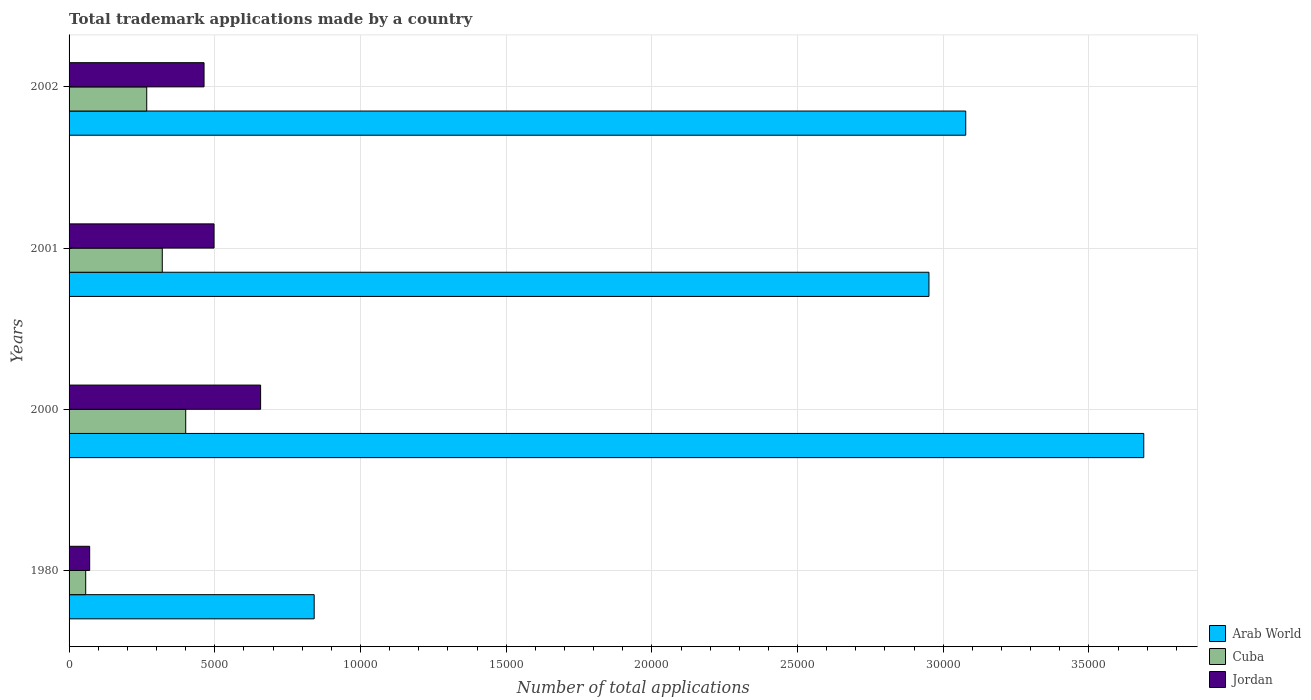Are the number of bars on each tick of the Y-axis equal?
Offer a very short reply. Yes. How many bars are there on the 2nd tick from the top?
Offer a terse response. 3. How many bars are there on the 1st tick from the bottom?
Your response must be concise. 3. What is the label of the 3rd group of bars from the top?
Make the answer very short. 2000. What is the number of applications made by in Jordan in 2001?
Provide a short and direct response. 4975. Across all years, what is the maximum number of applications made by in Jordan?
Offer a very short reply. 6573. Across all years, what is the minimum number of applications made by in Arab World?
Ensure brevity in your answer.  8411. In which year was the number of applications made by in Cuba maximum?
Make the answer very short. 2000. What is the total number of applications made by in Jordan in the graph?
Ensure brevity in your answer.  1.69e+04. What is the difference between the number of applications made by in Arab World in 1980 and that in 2001?
Offer a terse response. -2.11e+04. What is the difference between the number of applications made by in Cuba in 2001 and the number of applications made by in Arab World in 2002?
Ensure brevity in your answer.  -2.76e+04. What is the average number of applications made by in Arab World per year?
Give a very brief answer. 2.64e+04. In the year 2002, what is the difference between the number of applications made by in Jordan and number of applications made by in Arab World?
Make the answer very short. -2.61e+04. In how many years, is the number of applications made by in Jordan greater than 6000 ?
Give a very brief answer. 1. What is the ratio of the number of applications made by in Arab World in 2000 to that in 2001?
Make the answer very short. 1.25. What is the difference between the highest and the second highest number of applications made by in Arab World?
Ensure brevity in your answer.  6110. What is the difference between the highest and the lowest number of applications made by in Cuba?
Your response must be concise. 3432. Is the sum of the number of applications made by in Arab World in 2000 and 2001 greater than the maximum number of applications made by in Cuba across all years?
Ensure brevity in your answer.  Yes. What does the 3rd bar from the top in 2002 represents?
Your response must be concise. Arab World. What does the 3rd bar from the bottom in 2001 represents?
Keep it short and to the point. Jordan. Are all the bars in the graph horizontal?
Keep it short and to the point. Yes. How many years are there in the graph?
Give a very brief answer. 4. What is the difference between two consecutive major ticks on the X-axis?
Ensure brevity in your answer.  5000. Are the values on the major ticks of X-axis written in scientific E-notation?
Ensure brevity in your answer.  No. Does the graph contain any zero values?
Your answer should be compact. No. How many legend labels are there?
Your answer should be compact. 3. What is the title of the graph?
Keep it short and to the point. Total trademark applications made by a country. What is the label or title of the X-axis?
Ensure brevity in your answer.  Number of total applications. What is the label or title of the Y-axis?
Offer a terse response. Years. What is the Number of total applications in Arab World in 1980?
Your response must be concise. 8411. What is the Number of total applications of Cuba in 1980?
Keep it short and to the point. 571. What is the Number of total applications of Jordan in 1980?
Give a very brief answer. 707. What is the Number of total applications in Arab World in 2000?
Your response must be concise. 3.69e+04. What is the Number of total applications of Cuba in 2000?
Provide a succinct answer. 4003. What is the Number of total applications of Jordan in 2000?
Provide a short and direct response. 6573. What is the Number of total applications of Arab World in 2001?
Provide a succinct answer. 2.95e+04. What is the Number of total applications of Cuba in 2001?
Your response must be concise. 3199. What is the Number of total applications in Jordan in 2001?
Offer a terse response. 4975. What is the Number of total applications in Arab World in 2002?
Provide a succinct answer. 3.08e+04. What is the Number of total applications in Cuba in 2002?
Keep it short and to the point. 2665. What is the Number of total applications of Jordan in 2002?
Your answer should be compact. 4632. Across all years, what is the maximum Number of total applications in Arab World?
Offer a very short reply. 3.69e+04. Across all years, what is the maximum Number of total applications of Cuba?
Provide a succinct answer. 4003. Across all years, what is the maximum Number of total applications of Jordan?
Ensure brevity in your answer.  6573. Across all years, what is the minimum Number of total applications of Arab World?
Your answer should be compact. 8411. Across all years, what is the minimum Number of total applications of Cuba?
Your answer should be very brief. 571. Across all years, what is the minimum Number of total applications of Jordan?
Offer a terse response. 707. What is the total Number of total applications of Arab World in the graph?
Ensure brevity in your answer.  1.06e+05. What is the total Number of total applications of Cuba in the graph?
Offer a very short reply. 1.04e+04. What is the total Number of total applications in Jordan in the graph?
Your answer should be very brief. 1.69e+04. What is the difference between the Number of total applications of Arab World in 1980 and that in 2000?
Provide a short and direct response. -2.85e+04. What is the difference between the Number of total applications in Cuba in 1980 and that in 2000?
Provide a succinct answer. -3432. What is the difference between the Number of total applications of Jordan in 1980 and that in 2000?
Provide a succinct answer. -5866. What is the difference between the Number of total applications of Arab World in 1980 and that in 2001?
Ensure brevity in your answer.  -2.11e+04. What is the difference between the Number of total applications in Cuba in 1980 and that in 2001?
Ensure brevity in your answer.  -2628. What is the difference between the Number of total applications of Jordan in 1980 and that in 2001?
Ensure brevity in your answer.  -4268. What is the difference between the Number of total applications in Arab World in 1980 and that in 2002?
Give a very brief answer. -2.24e+04. What is the difference between the Number of total applications in Cuba in 1980 and that in 2002?
Offer a terse response. -2094. What is the difference between the Number of total applications of Jordan in 1980 and that in 2002?
Make the answer very short. -3925. What is the difference between the Number of total applications of Arab World in 2000 and that in 2001?
Keep it short and to the point. 7372. What is the difference between the Number of total applications of Cuba in 2000 and that in 2001?
Ensure brevity in your answer.  804. What is the difference between the Number of total applications of Jordan in 2000 and that in 2001?
Keep it short and to the point. 1598. What is the difference between the Number of total applications of Arab World in 2000 and that in 2002?
Your answer should be compact. 6110. What is the difference between the Number of total applications of Cuba in 2000 and that in 2002?
Offer a terse response. 1338. What is the difference between the Number of total applications in Jordan in 2000 and that in 2002?
Offer a terse response. 1941. What is the difference between the Number of total applications of Arab World in 2001 and that in 2002?
Offer a terse response. -1262. What is the difference between the Number of total applications of Cuba in 2001 and that in 2002?
Your answer should be very brief. 534. What is the difference between the Number of total applications in Jordan in 2001 and that in 2002?
Your answer should be very brief. 343. What is the difference between the Number of total applications of Arab World in 1980 and the Number of total applications of Cuba in 2000?
Offer a very short reply. 4408. What is the difference between the Number of total applications in Arab World in 1980 and the Number of total applications in Jordan in 2000?
Keep it short and to the point. 1838. What is the difference between the Number of total applications of Cuba in 1980 and the Number of total applications of Jordan in 2000?
Make the answer very short. -6002. What is the difference between the Number of total applications of Arab World in 1980 and the Number of total applications of Cuba in 2001?
Offer a terse response. 5212. What is the difference between the Number of total applications in Arab World in 1980 and the Number of total applications in Jordan in 2001?
Provide a short and direct response. 3436. What is the difference between the Number of total applications in Cuba in 1980 and the Number of total applications in Jordan in 2001?
Your answer should be compact. -4404. What is the difference between the Number of total applications of Arab World in 1980 and the Number of total applications of Cuba in 2002?
Make the answer very short. 5746. What is the difference between the Number of total applications in Arab World in 1980 and the Number of total applications in Jordan in 2002?
Offer a terse response. 3779. What is the difference between the Number of total applications in Cuba in 1980 and the Number of total applications in Jordan in 2002?
Ensure brevity in your answer.  -4061. What is the difference between the Number of total applications of Arab World in 2000 and the Number of total applications of Cuba in 2001?
Provide a short and direct response. 3.37e+04. What is the difference between the Number of total applications of Arab World in 2000 and the Number of total applications of Jordan in 2001?
Your answer should be very brief. 3.19e+04. What is the difference between the Number of total applications of Cuba in 2000 and the Number of total applications of Jordan in 2001?
Provide a succinct answer. -972. What is the difference between the Number of total applications in Arab World in 2000 and the Number of total applications in Cuba in 2002?
Ensure brevity in your answer.  3.42e+04. What is the difference between the Number of total applications in Arab World in 2000 and the Number of total applications in Jordan in 2002?
Offer a terse response. 3.22e+04. What is the difference between the Number of total applications of Cuba in 2000 and the Number of total applications of Jordan in 2002?
Offer a very short reply. -629. What is the difference between the Number of total applications in Arab World in 2001 and the Number of total applications in Cuba in 2002?
Offer a terse response. 2.68e+04. What is the difference between the Number of total applications of Arab World in 2001 and the Number of total applications of Jordan in 2002?
Make the answer very short. 2.49e+04. What is the difference between the Number of total applications in Cuba in 2001 and the Number of total applications in Jordan in 2002?
Make the answer very short. -1433. What is the average Number of total applications in Arab World per year?
Your response must be concise. 2.64e+04. What is the average Number of total applications of Cuba per year?
Ensure brevity in your answer.  2609.5. What is the average Number of total applications of Jordan per year?
Give a very brief answer. 4221.75. In the year 1980, what is the difference between the Number of total applications in Arab World and Number of total applications in Cuba?
Your answer should be compact. 7840. In the year 1980, what is the difference between the Number of total applications of Arab World and Number of total applications of Jordan?
Your response must be concise. 7704. In the year 1980, what is the difference between the Number of total applications of Cuba and Number of total applications of Jordan?
Provide a short and direct response. -136. In the year 2000, what is the difference between the Number of total applications in Arab World and Number of total applications in Cuba?
Provide a succinct answer. 3.29e+04. In the year 2000, what is the difference between the Number of total applications in Arab World and Number of total applications in Jordan?
Give a very brief answer. 3.03e+04. In the year 2000, what is the difference between the Number of total applications in Cuba and Number of total applications in Jordan?
Your response must be concise. -2570. In the year 2001, what is the difference between the Number of total applications in Arab World and Number of total applications in Cuba?
Your answer should be very brief. 2.63e+04. In the year 2001, what is the difference between the Number of total applications in Arab World and Number of total applications in Jordan?
Your answer should be very brief. 2.45e+04. In the year 2001, what is the difference between the Number of total applications in Cuba and Number of total applications in Jordan?
Make the answer very short. -1776. In the year 2002, what is the difference between the Number of total applications in Arab World and Number of total applications in Cuba?
Provide a short and direct response. 2.81e+04. In the year 2002, what is the difference between the Number of total applications of Arab World and Number of total applications of Jordan?
Give a very brief answer. 2.61e+04. In the year 2002, what is the difference between the Number of total applications of Cuba and Number of total applications of Jordan?
Offer a terse response. -1967. What is the ratio of the Number of total applications in Arab World in 1980 to that in 2000?
Keep it short and to the point. 0.23. What is the ratio of the Number of total applications of Cuba in 1980 to that in 2000?
Ensure brevity in your answer.  0.14. What is the ratio of the Number of total applications in Jordan in 1980 to that in 2000?
Your answer should be very brief. 0.11. What is the ratio of the Number of total applications in Arab World in 1980 to that in 2001?
Offer a very short reply. 0.28. What is the ratio of the Number of total applications of Cuba in 1980 to that in 2001?
Offer a terse response. 0.18. What is the ratio of the Number of total applications in Jordan in 1980 to that in 2001?
Ensure brevity in your answer.  0.14. What is the ratio of the Number of total applications of Arab World in 1980 to that in 2002?
Provide a short and direct response. 0.27. What is the ratio of the Number of total applications in Cuba in 1980 to that in 2002?
Your answer should be very brief. 0.21. What is the ratio of the Number of total applications in Jordan in 1980 to that in 2002?
Make the answer very short. 0.15. What is the ratio of the Number of total applications of Arab World in 2000 to that in 2001?
Your response must be concise. 1.25. What is the ratio of the Number of total applications in Cuba in 2000 to that in 2001?
Offer a very short reply. 1.25. What is the ratio of the Number of total applications of Jordan in 2000 to that in 2001?
Keep it short and to the point. 1.32. What is the ratio of the Number of total applications of Arab World in 2000 to that in 2002?
Your answer should be compact. 1.2. What is the ratio of the Number of total applications in Cuba in 2000 to that in 2002?
Your response must be concise. 1.5. What is the ratio of the Number of total applications in Jordan in 2000 to that in 2002?
Make the answer very short. 1.42. What is the ratio of the Number of total applications in Arab World in 2001 to that in 2002?
Your answer should be compact. 0.96. What is the ratio of the Number of total applications of Cuba in 2001 to that in 2002?
Offer a very short reply. 1.2. What is the ratio of the Number of total applications of Jordan in 2001 to that in 2002?
Offer a very short reply. 1.07. What is the difference between the highest and the second highest Number of total applications in Arab World?
Provide a short and direct response. 6110. What is the difference between the highest and the second highest Number of total applications of Cuba?
Give a very brief answer. 804. What is the difference between the highest and the second highest Number of total applications in Jordan?
Your answer should be compact. 1598. What is the difference between the highest and the lowest Number of total applications of Arab World?
Your response must be concise. 2.85e+04. What is the difference between the highest and the lowest Number of total applications in Cuba?
Provide a short and direct response. 3432. What is the difference between the highest and the lowest Number of total applications of Jordan?
Make the answer very short. 5866. 